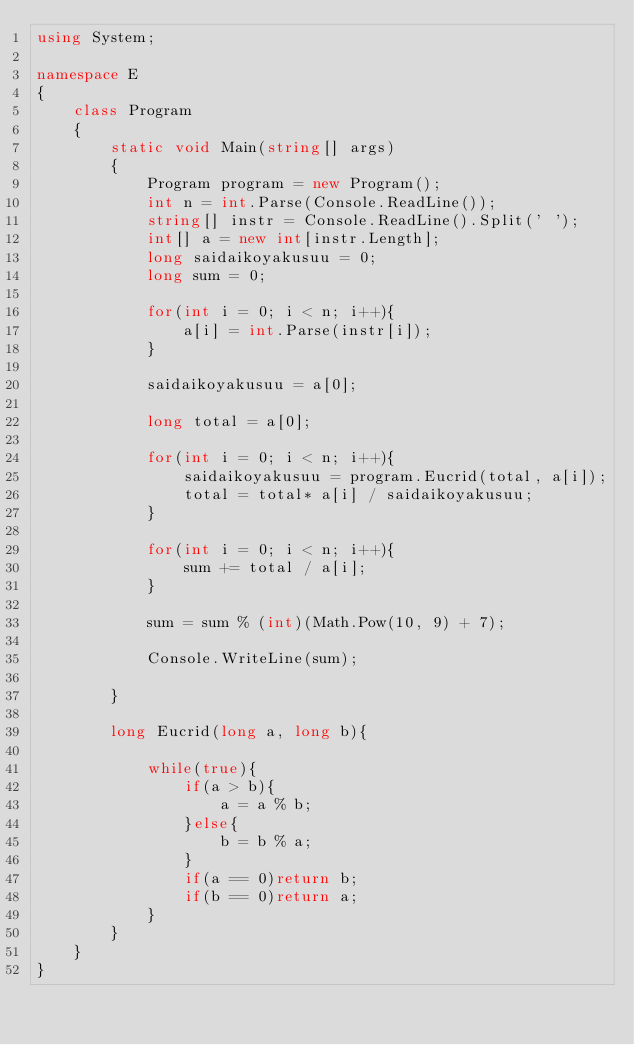Convert code to text. <code><loc_0><loc_0><loc_500><loc_500><_C#_>using System;

namespace E
{
    class Program
    {
        static void Main(string[] args)
        {
            Program program = new Program();
            int n = int.Parse(Console.ReadLine());
            string[] instr = Console.ReadLine().Split(' ');
            int[] a = new int[instr.Length];
            long saidaikoyakusuu = 0;
            long sum = 0;

            for(int i = 0; i < n; i++){
                a[i] = int.Parse(instr[i]);
            }

            saidaikoyakusuu = a[0];

            long total = a[0];

            for(int i = 0; i < n; i++){
                saidaikoyakusuu = program.Eucrid(total, a[i]);
                total = total* a[i] / saidaikoyakusuu;
            }

            for(int i = 0; i < n; i++){
                sum += total / a[i];
            }

            sum = sum % (int)(Math.Pow(10, 9) + 7);

            Console.WriteLine(sum);

        }

        long Eucrid(long a, long b){

            while(true){
                if(a > b){
                    a = a % b;
                }else{
                    b = b % a;
                }
                if(a == 0)return b;
                if(b == 0)return a;
            }
        }
    }
}
</code> 